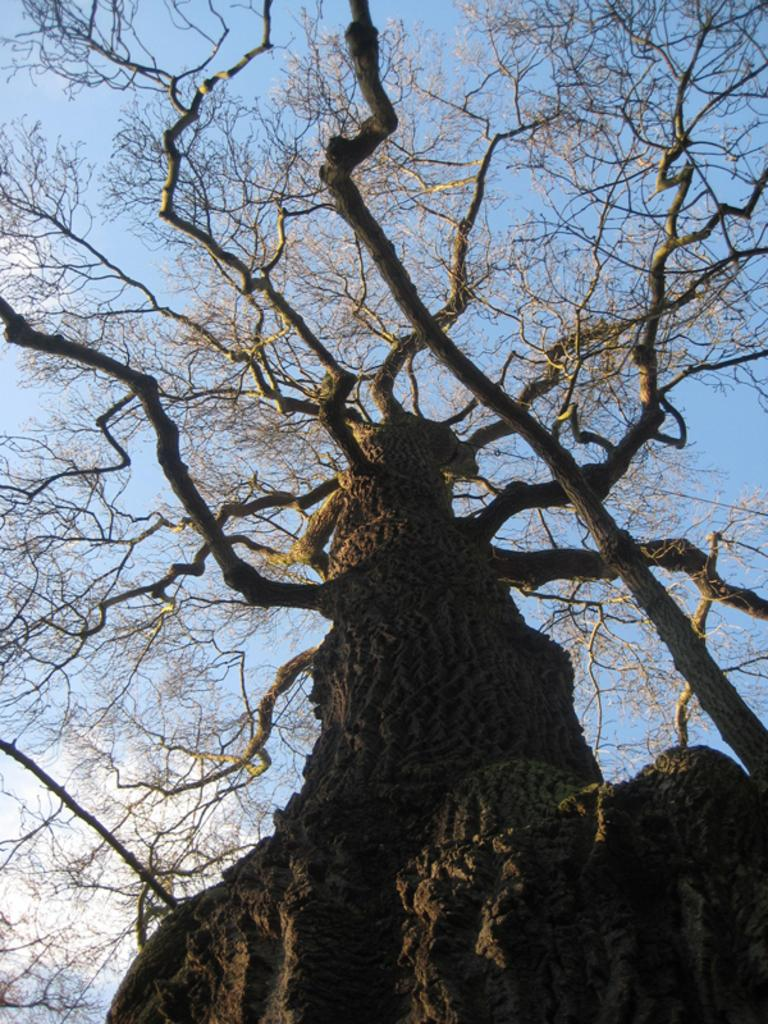What type of vegetation can be seen in the image? There are dried trees in the image. What is visible in the background of the image? The sky is visible in the background of the image. What colors are present in the sky? The sky has a blue and white color. What type of lipstick is the tree wearing in the image? There are no trees wearing lipstick in the image, as trees do not have the ability to wear makeup. 